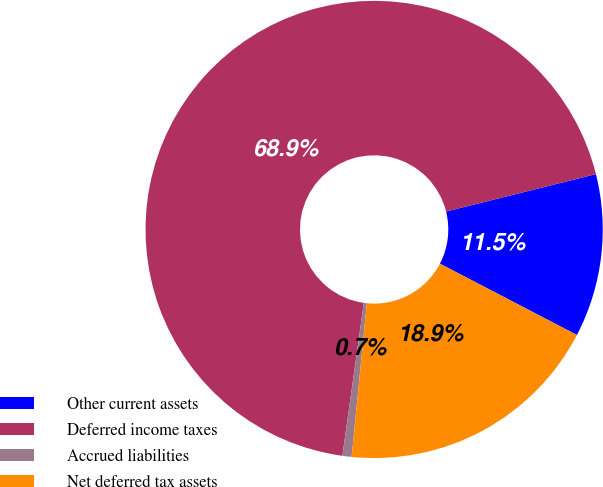Convert chart to OTSL. <chart><loc_0><loc_0><loc_500><loc_500><pie_chart><fcel>Other current assets<fcel>Deferred income taxes<fcel>Accrued liabilities<fcel>Net deferred tax assets<nl><fcel>11.53%<fcel>68.88%<fcel>0.65%<fcel>18.93%<nl></chart> 